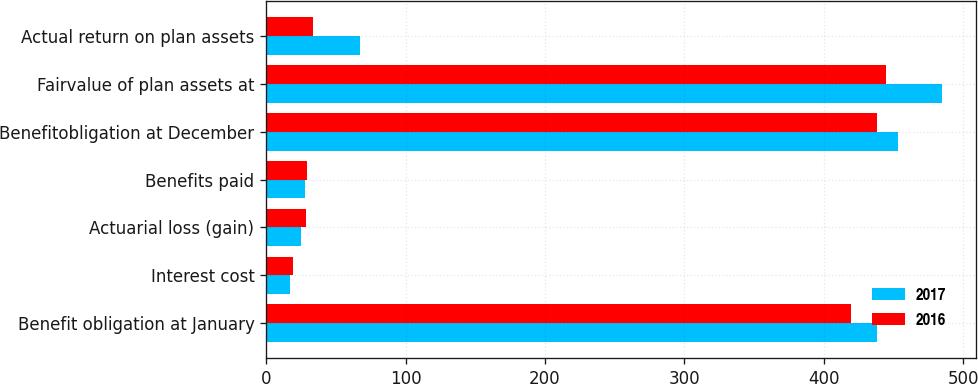<chart> <loc_0><loc_0><loc_500><loc_500><stacked_bar_chart><ecel><fcel>Benefit obligation at January<fcel>Interest cost<fcel>Actuarial loss (gain)<fcel>Benefits paid<fcel>Benefitobligation at December<fcel>Fairvalue of plan assets at<fcel>Actual return on plan assets<nl><fcel>2017<fcel>438.4<fcel>17.1<fcel>25.4<fcel>28<fcel>452.9<fcel>484.7<fcel>67.3<nl><fcel>2016<fcel>419.6<fcel>19.3<fcel>28.5<fcel>29<fcel>438.4<fcel>444.5<fcel>33.9<nl></chart> 